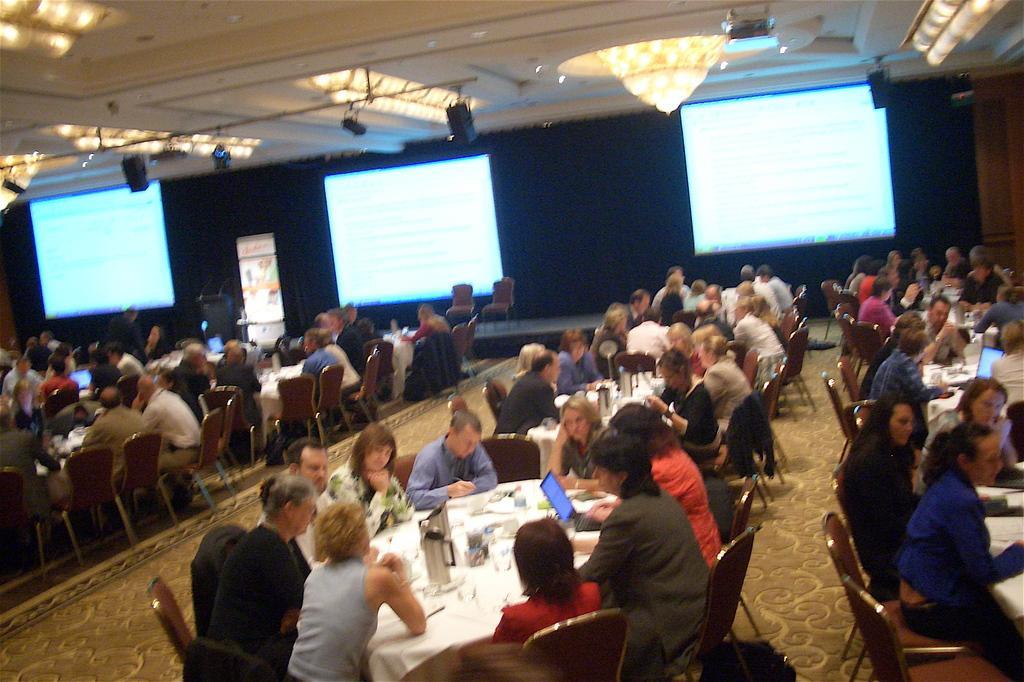Could you give a brief overview of what you see in this image? In this picture I can see group of people sitting on the chairs. I can see jugs, glasses, laptops and some other objects on the tables. There are projector screens, focus lights, chandeliers, projectors and some other objects. 